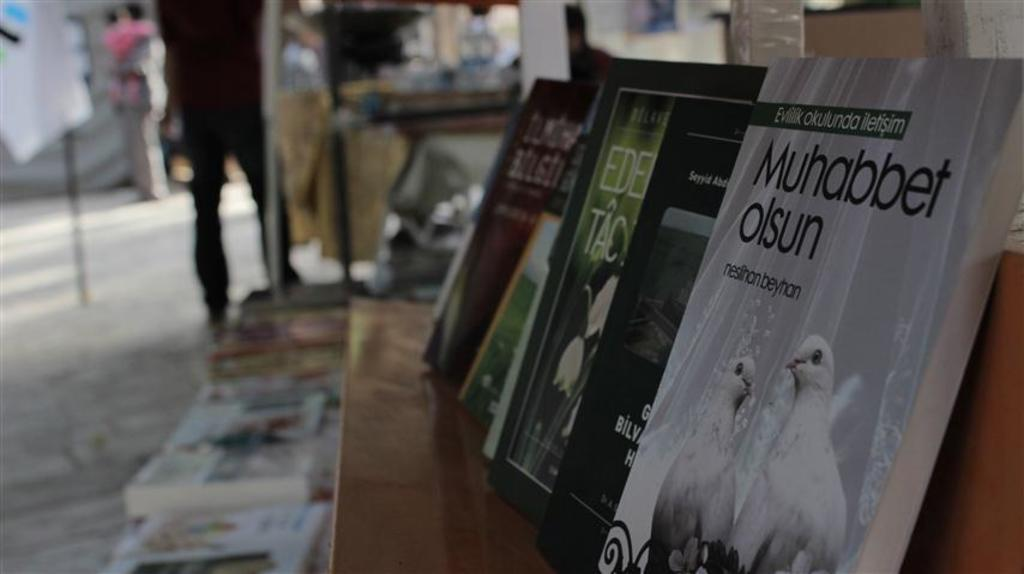Provide a one-sentence caption for the provided image. A row of books one of which says Muhabbet olsun. 